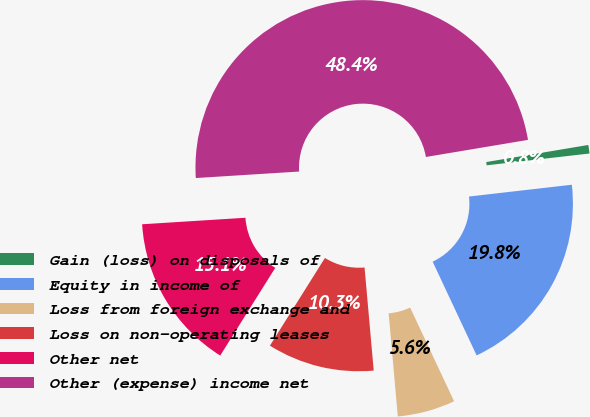Convert chart. <chart><loc_0><loc_0><loc_500><loc_500><pie_chart><fcel>Gain (loss) on disposals of<fcel>Equity in income of<fcel>Loss from foreign exchange and<fcel>Loss on non-operating leases<fcel>Other net<fcel>Other (expense) income net<nl><fcel>0.82%<fcel>19.84%<fcel>5.57%<fcel>10.33%<fcel>15.08%<fcel>48.36%<nl></chart> 